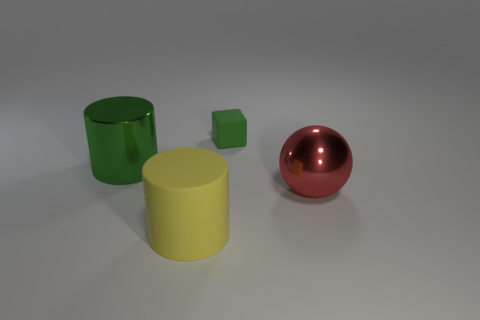Is there anything else that has the same shape as the tiny thing?
Your response must be concise. No. Are there any yellow objects on the left side of the yellow rubber cylinder?
Provide a succinct answer. No. What number of metallic objects are red things or small purple spheres?
Give a very brief answer. 1. There is a small green cube; what number of big yellow matte objects are right of it?
Make the answer very short. 0. Are there any green rubber spheres of the same size as the metal cylinder?
Offer a very short reply. No. Are there any shiny cylinders of the same color as the tiny rubber thing?
Ensure brevity in your answer.  Yes. Are there any other things that have the same size as the green cube?
Ensure brevity in your answer.  No. What number of large spheres are the same color as the tiny thing?
Your answer should be compact. 0. There is a tiny cube; is its color the same as the cylinder that is left of the yellow rubber cylinder?
Offer a very short reply. Yes. How many objects are either yellow matte cylinders or cylinders that are behind the big red object?
Make the answer very short. 2. 